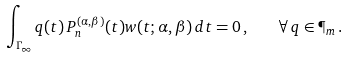<formula> <loc_0><loc_0><loc_500><loc_500>\int _ { \Gamma _ { \infty } } q ( t ) \, P _ { n } ^ { ( \alpha , \beta ) } ( t ) w ( t ; \alpha , \beta ) \, d t = 0 \, , \quad \forall \, q \in \P _ { m } \, .</formula> 